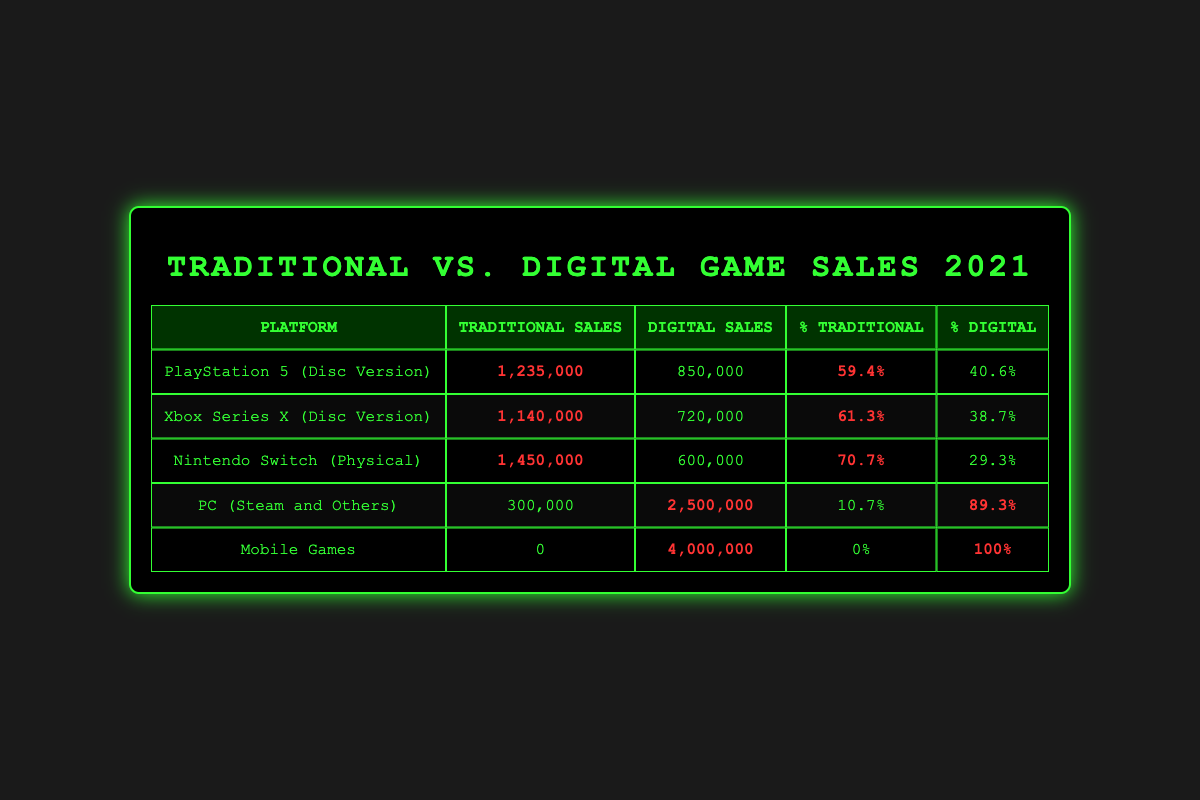What is the traditional sales figure for Nintendo Switch (Physical)? The table lists the sales figures for Nintendo Switch (Physical) under the column "Traditional Sales," which shows 1,450,000.
Answer: 1,450,000 Which platform had the highest percentage of digital sales? To find the highest percentage of digital sales, we check the column "% Digital" and see that Mobile Games has 100%, which is greater than all other platforms listed.
Answer: Mobile Games What is the total traditional sales across all platforms? To calculate total traditional sales, we sum the values from the "Traditional Sales" column: 1,235,000 (PS5) + 1,140,000 (Xbox Series X) + 1,450,000 (Nintendo Switch) + 300,000 (PC) + 0 (Mobile) = 4,125,000.
Answer: 4,125,000 Is the percentage of traditional sales for PC higher than for PlayStation 5? The percentage of traditional sales for PC is 10.7%, while for PlayStation 5, it is 59.4%. Since 10.7% is less than 59.4%, the answer is no.
Answer: No By what percentage is the digital sales for PC greater than the traditional sales? To find out by what percentage the digital sales for PC are greater than traditional sales, we use the values: Digital sales (2,500,000) - Traditional sales (300,000) = 2,200,000. Now, (2,200,000 / 300,000) * 100% = 733.3%.
Answer: 733.3% 